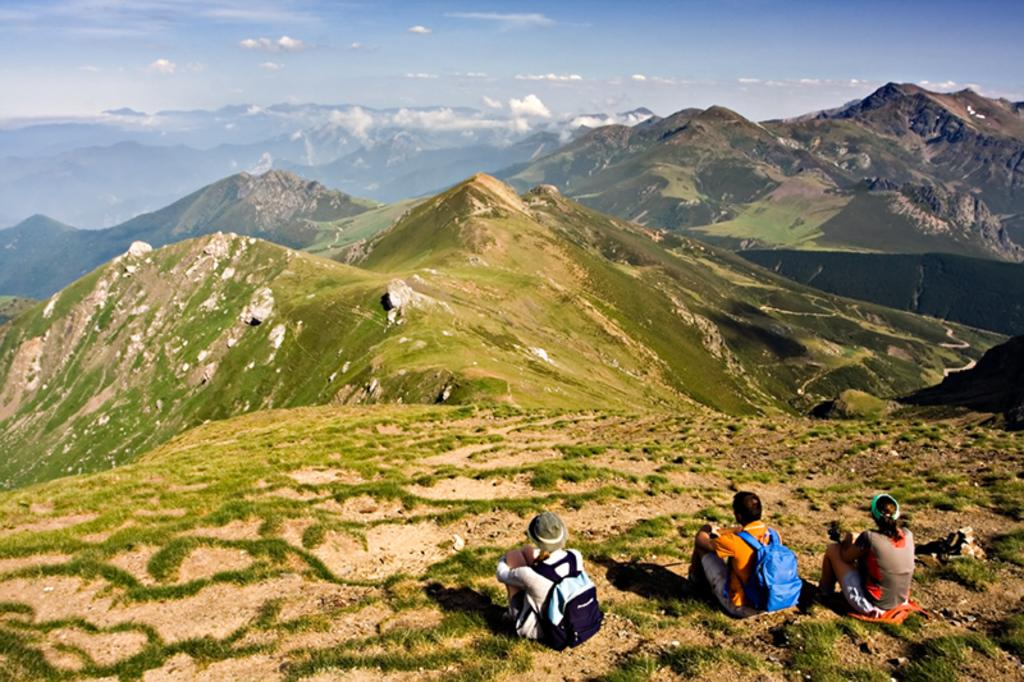How many people are sitting in the image? There are three people sitting in the image. What are two of the people wearing? Two of the people are wearing bags. What can be seen in the background of the image? There are mountains and the sky visible in the background of the image. What is the condition of the sky in the image? The sky is visible in the background of the image, and there are clouds present. What type of vegetation is on the mountains? There is grass on the mountains. What type of beast can be seen playing with balls in the image? There is no beast or balls present in the image; it features three people sitting and a background with mountains and the sky. 